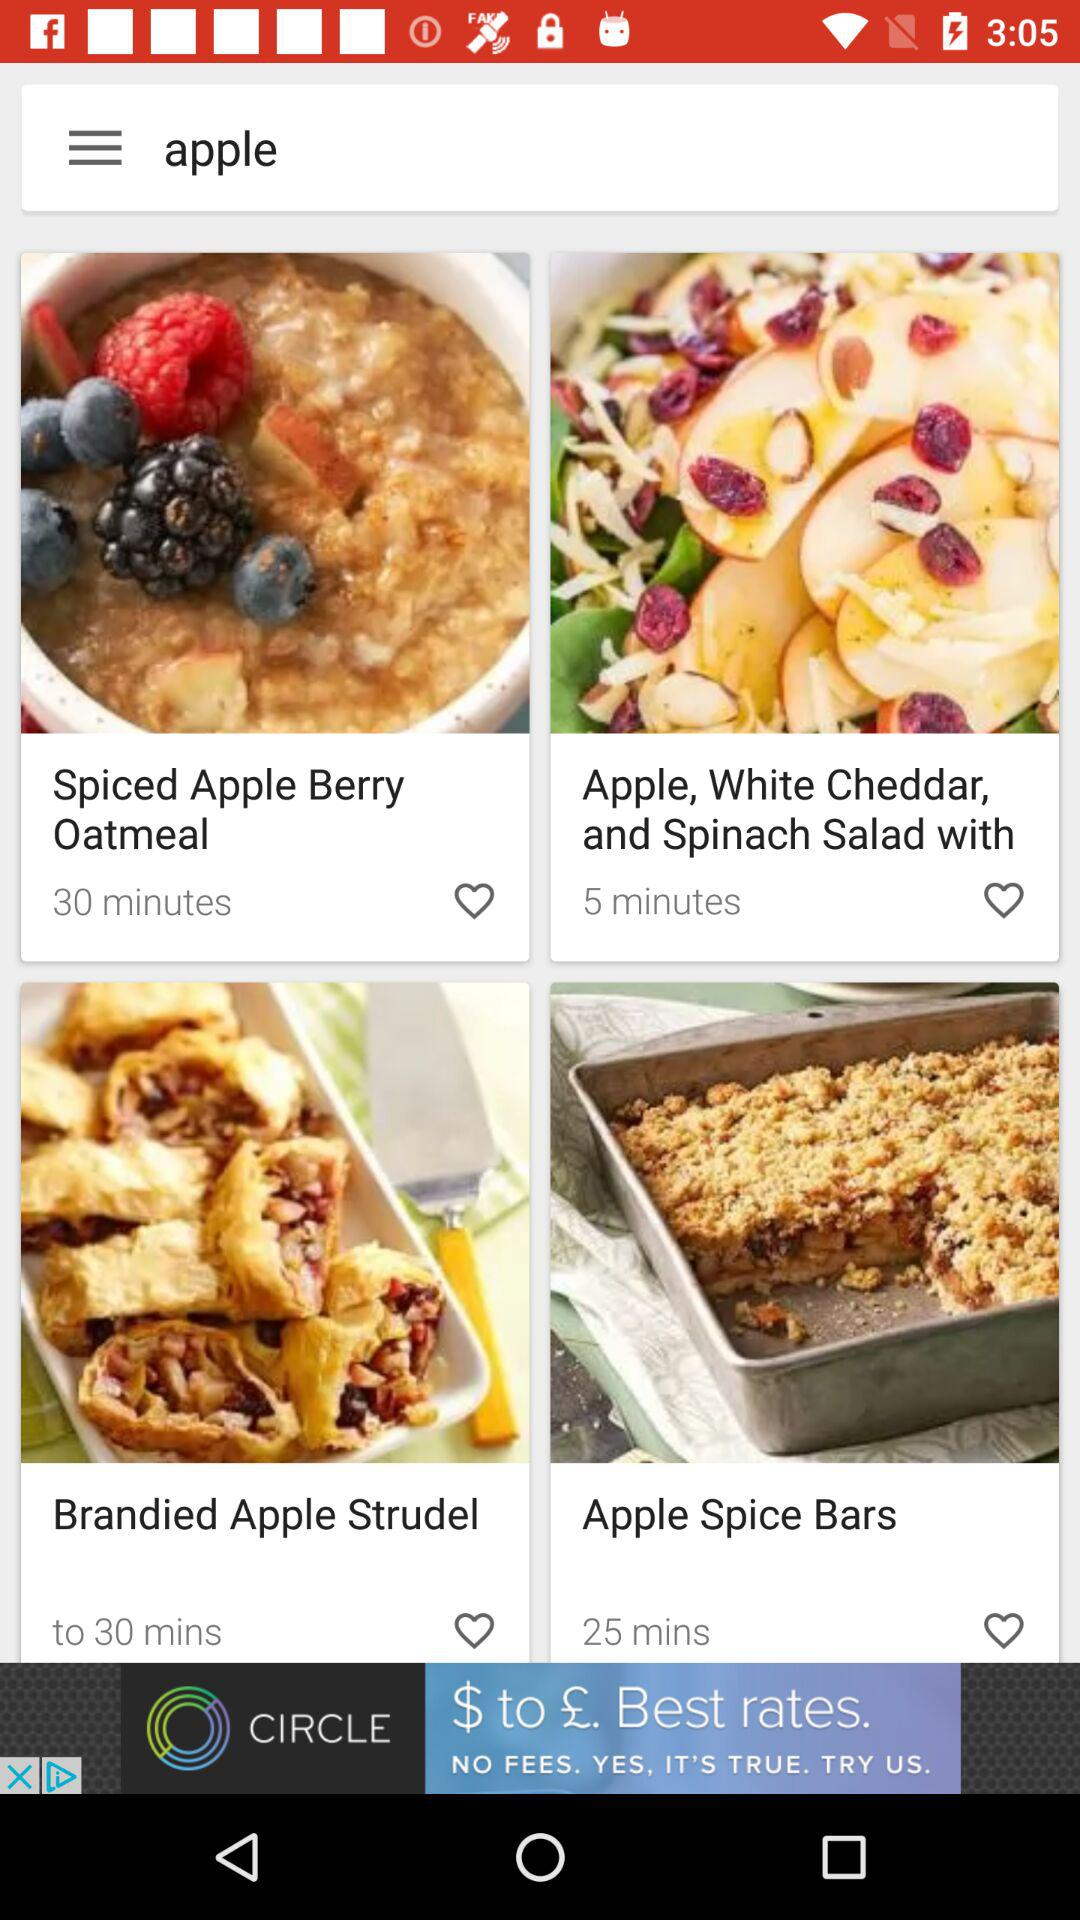What fruit dishes are there? The fruit is apple. 